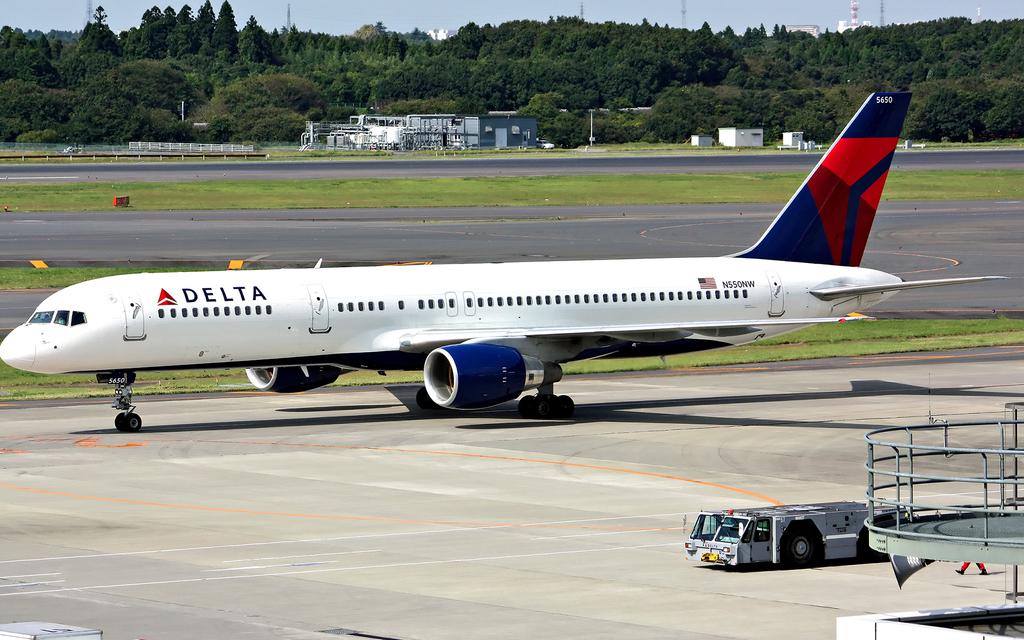What airlines is shown?
Your response must be concise. Delta. 